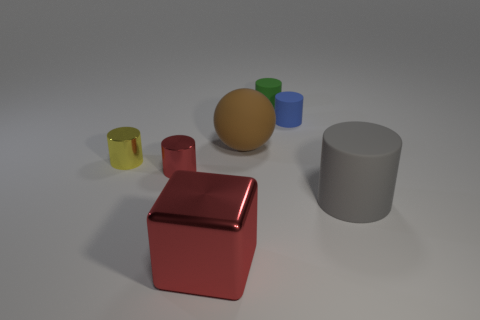Subtract all green rubber cylinders. How many cylinders are left? 4 Add 3 large blue metal blocks. How many objects exist? 10 Subtract all cubes. How many objects are left? 6 Subtract 1 yellow cylinders. How many objects are left? 6 Subtract all green rubber objects. Subtract all tiny green metallic things. How many objects are left? 6 Add 4 small green cylinders. How many small green cylinders are left? 5 Add 4 small matte cubes. How many small matte cubes exist? 4 